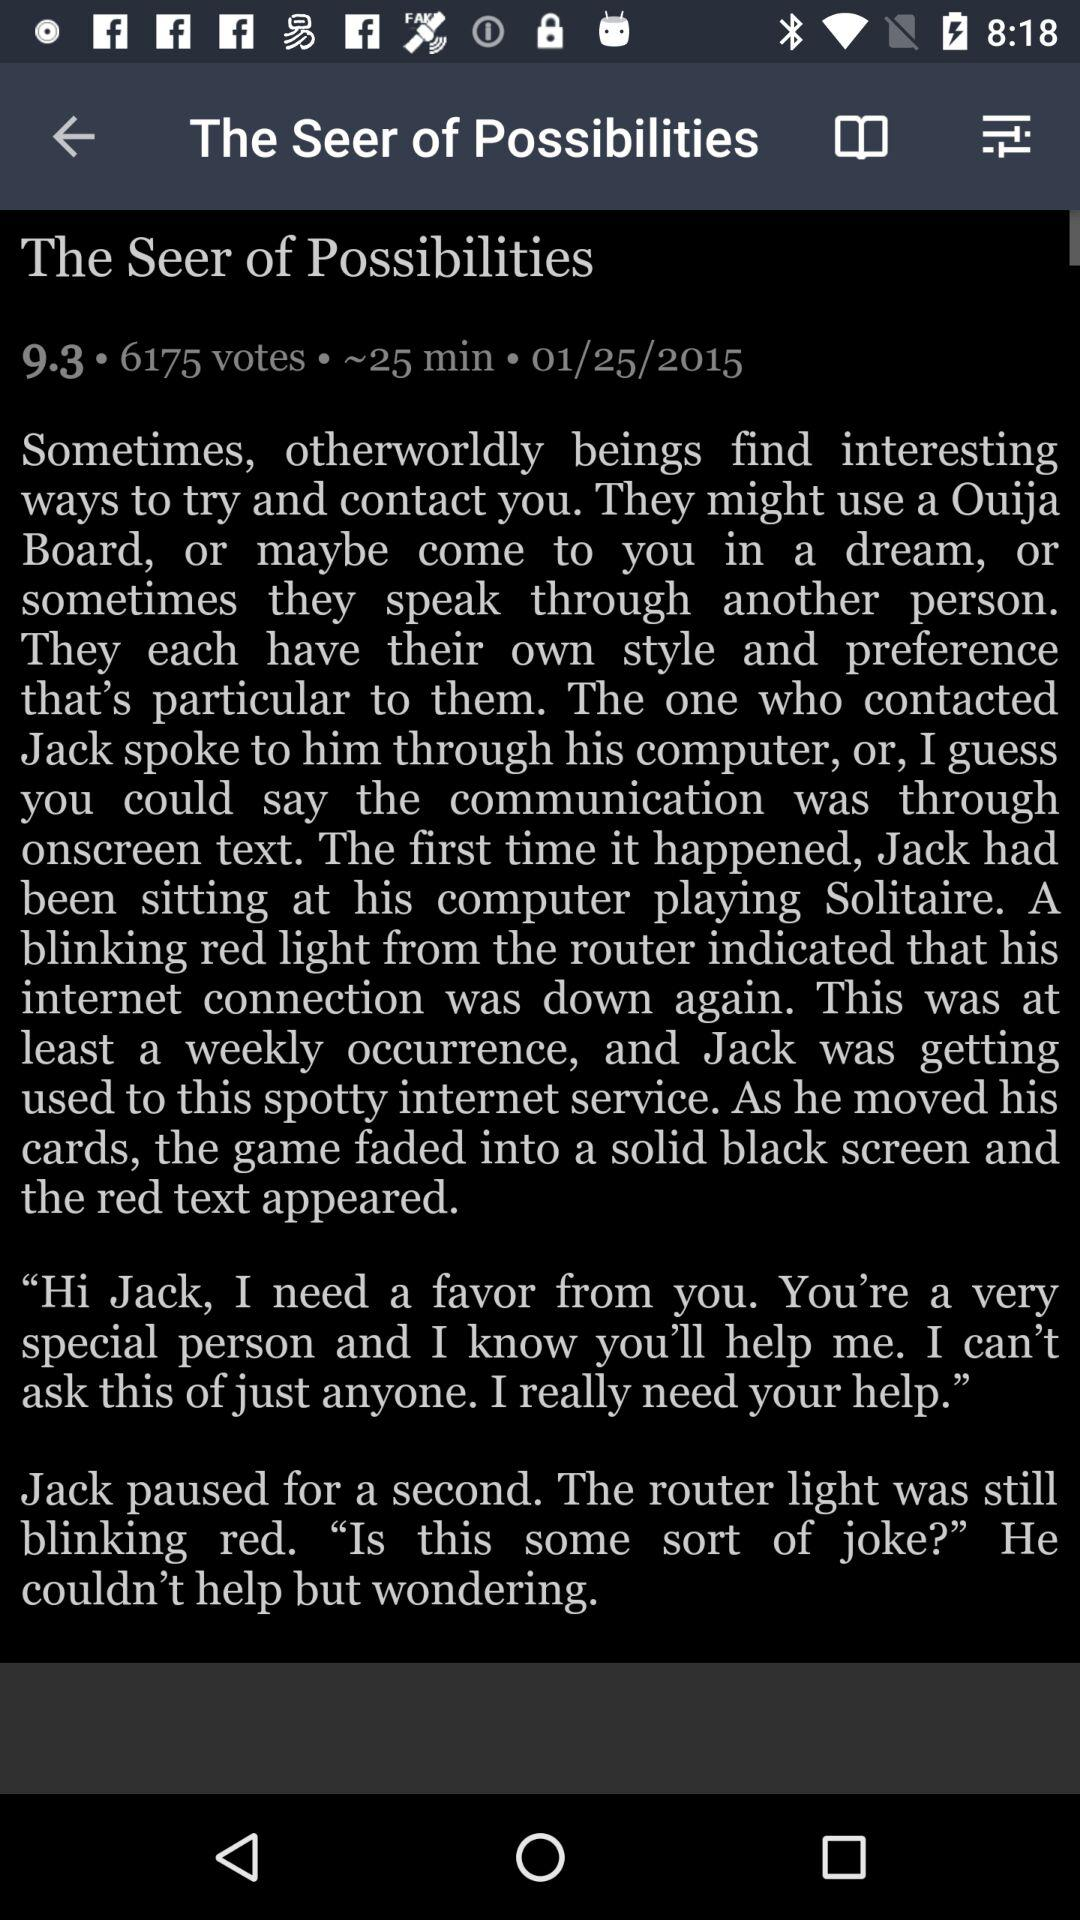What's the reading duration of the article? The reading duration of the article is approximately 25 minutes. 